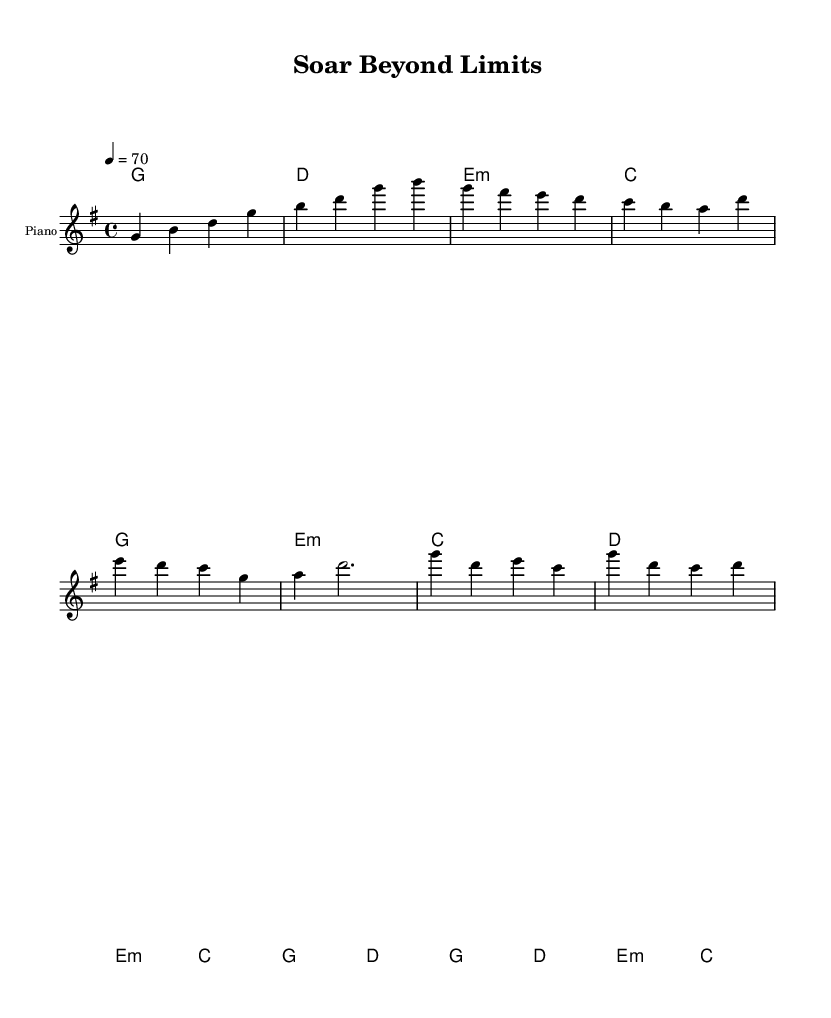What is the key signature of this music? The key signature is G major, which has one sharp, F#. This can be determined by looking for the sharp signs in the key signature area on the sheet music.
Answer: G major What is the time signature of this music? The time signature is 4/4, shown at the beginning of the piece. This indicates that there are four beats in each measure, and the quarter note gets one beat.
Answer: 4/4 What is the tempo marking for this piece? The tempo marking is 70 beats per minute, indicated by the notation "4 = 70" at the start of the score. This informs performers how fast to play the piece.
Answer: 70 How many measures are in the verse section? The verse section consists of 4 measures, which can be counted by looking at the line that includes the melody notes labeled as 'Verse' in the sheet music.
Answer: 4 What chord follows the Pre-Chorus section? The chord following the Pre-Chorus is D major. This can be determined by examining the harmonies section that shows the progression and identifying the chords under the Pre-Chorus section.
Answer: D major What is the theme of the lyrics provided? The theme of the lyrics centers around perseverance and achieving dreams, as indicated by phrases like "strength to persevere" and "victory awaits." This shows the motivational aspect typical of K-Pop ballads.
Answer: Perseverance and achievement 